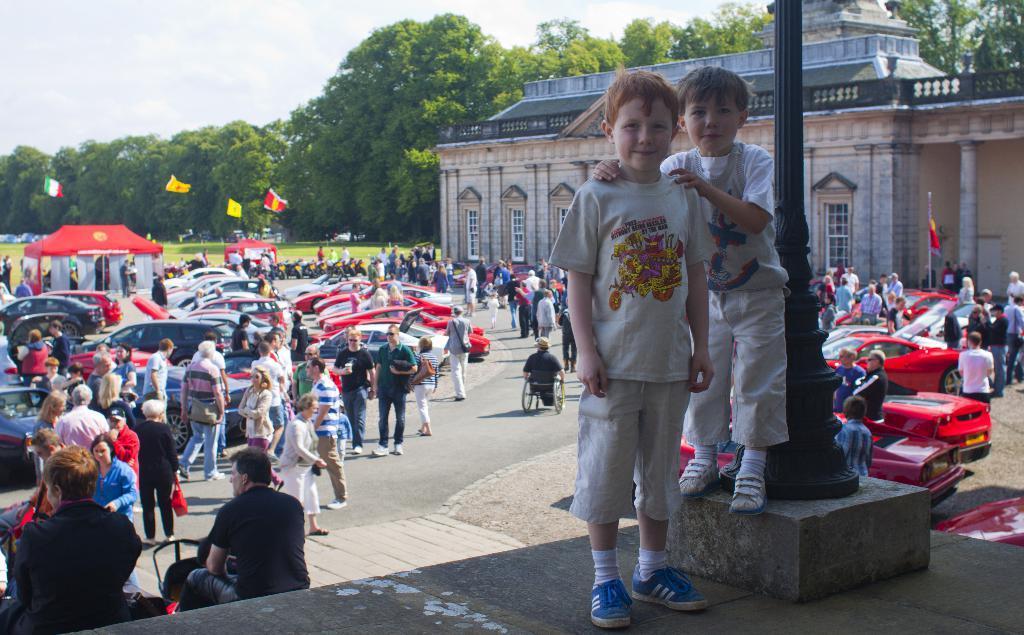Can you describe this image briefly? In the center of the image there is a platform. On the platform, we can see one pole and two kids are standing and they are smiling. In the background, we can see the sky, clouds, trees, grass, flags, tents, one building, few vehicles, few people are standing, few people are sitting, few people are walking, few people are holding some objects and a few other objects. 